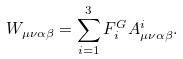Convert formula to latex. <formula><loc_0><loc_0><loc_500><loc_500>W _ { \mu \nu \alpha \beta } = \sum _ { i = 1 } ^ { 3 } F ^ { G } _ { i } A ^ { i } _ { \mu \nu \alpha \beta } .</formula> 